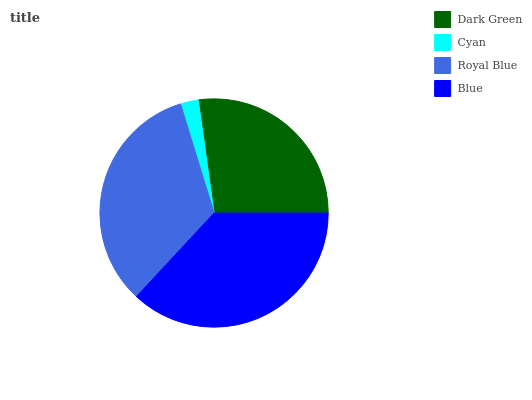Is Cyan the minimum?
Answer yes or no. Yes. Is Blue the maximum?
Answer yes or no. Yes. Is Royal Blue the minimum?
Answer yes or no. No. Is Royal Blue the maximum?
Answer yes or no. No. Is Royal Blue greater than Cyan?
Answer yes or no. Yes. Is Cyan less than Royal Blue?
Answer yes or no. Yes. Is Cyan greater than Royal Blue?
Answer yes or no. No. Is Royal Blue less than Cyan?
Answer yes or no. No. Is Royal Blue the high median?
Answer yes or no. Yes. Is Dark Green the low median?
Answer yes or no. Yes. Is Blue the high median?
Answer yes or no. No. Is Blue the low median?
Answer yes or no. No. 